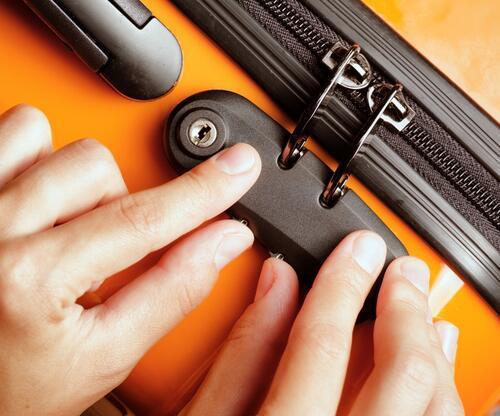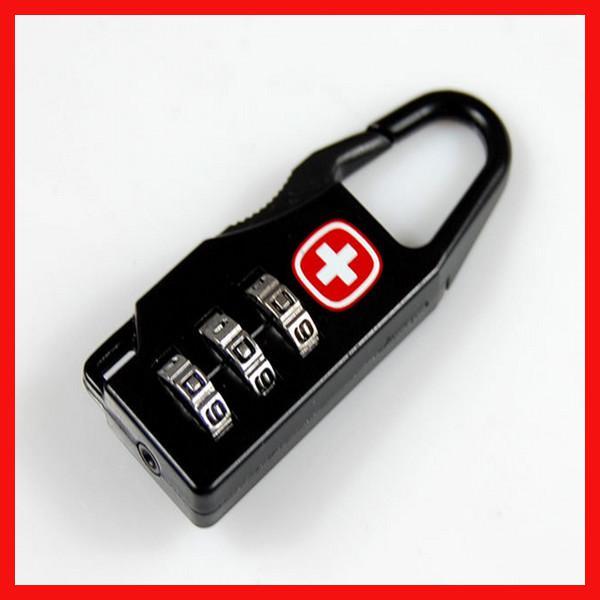The first image is the image on the left, the second image is the image on the right. Given the left and right images, does the statement "There are two locks attached to bags." hold true? Answer yes or no. No. The first image is the image on the left, the second image is the image on the right. Given the left and right images, does the statement "There are two thumbs in on e of the images." hold true? Answer yes or no. Yes. 